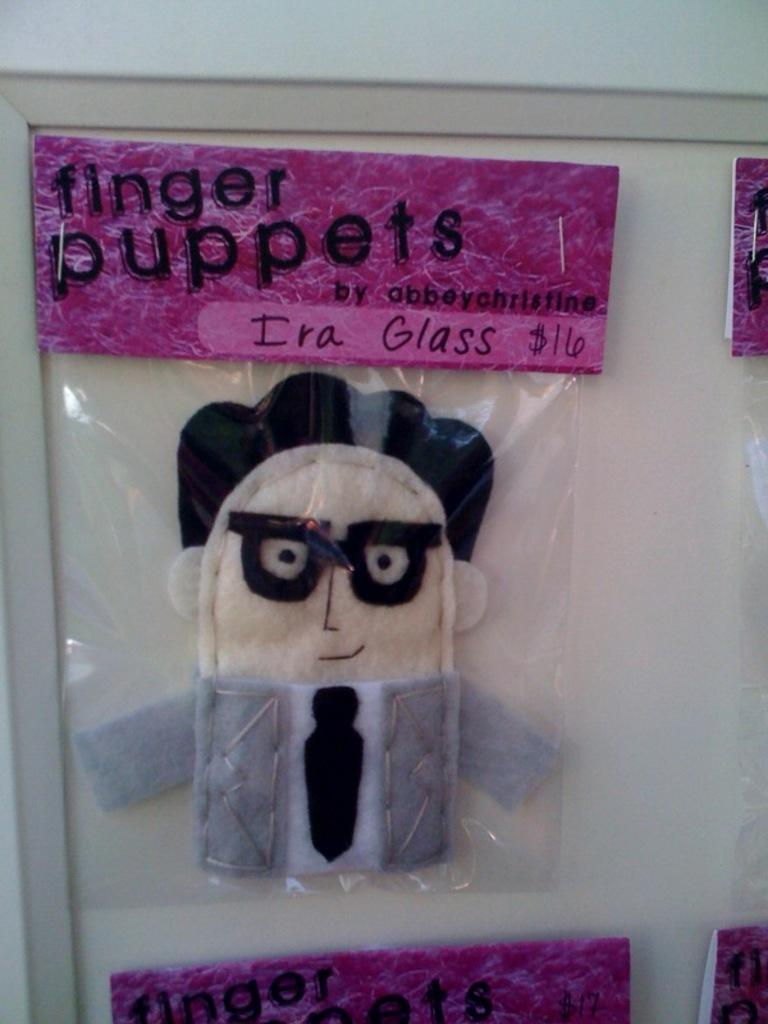What is the main object in the image? There is a frame in the image. What is attached to the frame? A toy is pinned to the frame, and there are multiple packets pinned to the frame as well. Can you describe one of the packets on the frame? There is a packet with a paper and text on it in the image. What type of wax is used to attach the toy to the frame? There is no mention of wax being used to attach the toy to the frame in the image. --- Facts: 1. There is a person sitting on a chair in the image. 2. The person is holding a book. 3. There is a table next to the chair. 4. A lamp is on the table. 5. The background of the image is a wall. Absurd Topics: parrot, ocean, bicycle Conversation: What is the person in the image doing? The person is sitting on a chair in the image. What is the person holding while sitting on the chair? The person is holding a book. What is located next to the chair? There is a table next to the chair. What is on the table? A lamp is on the table. What can be seen behind the person? The background of the image is a wall. Reasoning: Let's think step by step in order to produce the conversation. We start by describing the main subject in the image, which is the person sitting on a chair. Then, we expand the conversation to include what the person is holding (a book) and the objects located near the chair (a table and a lamp). Finally, we describe the background of the image, which is a wall. Absurd Question/Answer: Can you see a parrot sitting on the person's shoulder in the image? No, there is no parrot present in the image. --- Facts: 1. There is a person standing in front of a mirror in the image. 2. The person is wearing a hat. 3. The mirror is reflecting the person's image. 4. There is a shelf above the mirror. 5. The shelf has items on it. Absurd Topics: elephant, rain, umbrella Conversation: What is the person in the image doing? The person is standing in front of a mirror in the image. What is the person wearing on their head? The person is wearing a hat. What is the mirror showing in the image? The mirror is reflecting the person's image. What is located above the mirror? There is a shelf above the mirror. What can be seen on the shelf? The shelf has items on it. Reasoning: Let's think step by step in order to produce the conversation. We start by describing the main subject in the image, which is the person standing in front 